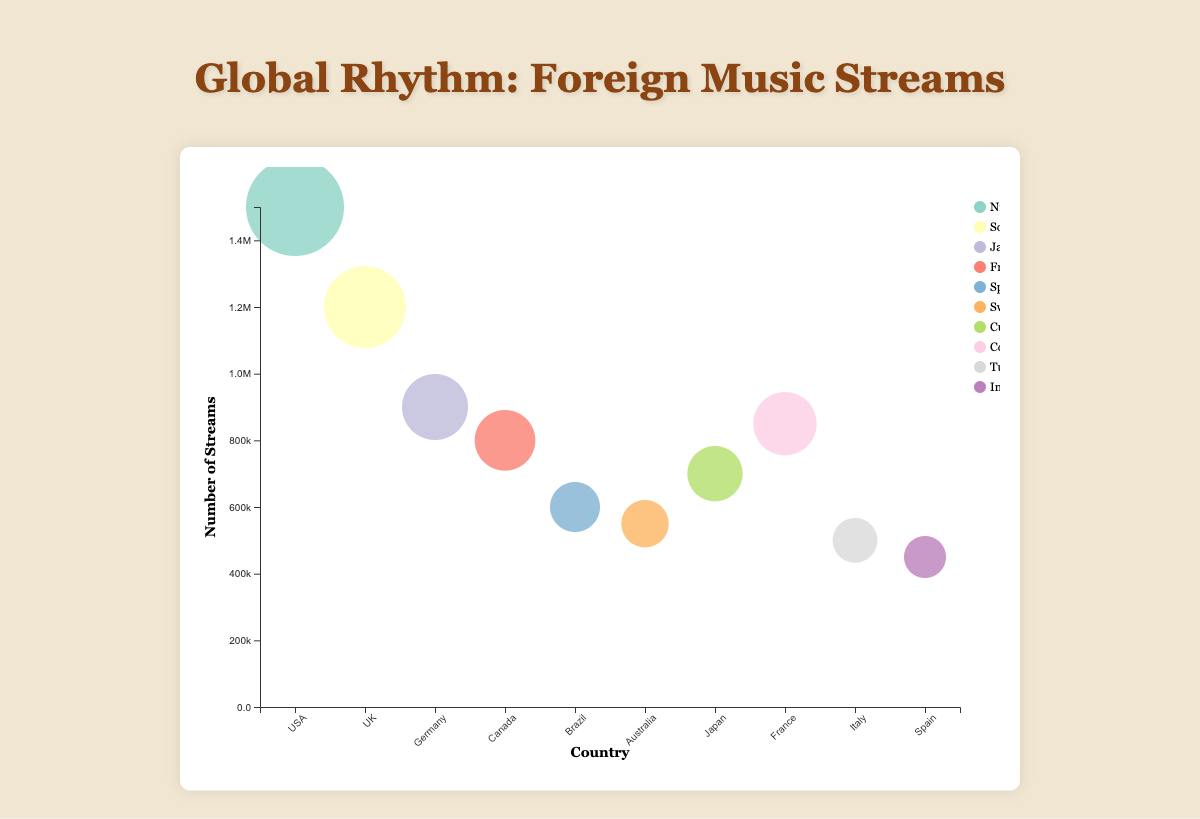Which country streams Burna Boy the most? First, locate the bubble labeled "Burna Boy" (artist from Nigeria). Observe its position on the x-axis to find the corresponding country, which is the USA.
Answer: USA What is the total number of streams for artists originating in Africa? Identify artists from Africa by looking at their origins. Burna Boy (Nigeria) has 1,500,000 streams. He is the only African artist in the figure. Sum the streams.
Answer: 1,500,000 Which artist has the smallest number of streams and in which country? Find the smallest bubble. The smallest one corresponds to A. R. Rahman (India) in Spain.
Answer: A. R. Rahman (Spain) How many countries are represented in the bubble chart? Count the unique countries listed on the x-axis. Countries are USA, UK, Germany, Canada, Brazil, Australia, Japan, France, Italy, Spain.
Answer: 10 Compare the number of streams between Julien Doré in Canada and Bob Marley in Germany. Which artist has more streams? Check the bubbles for Julien Doré (800,000 streams) and Bob Marley (900,000 streams). Compare the numbers.
Answer: Bob Marley Which country streams the most music from Asia? Identify the artists from Asian countries (South Korea, India). Compare the bubble sizes for BTS (1,200,000 streams, UK) and A. R. Rahman (450,000 streams, Spain). The country with the larger bubble streams the most.
Answer: UK What is the average number of streams for artists originating from Europe? Identify European-origin artists: Julien Doré (800,000), Tove Lo (550,000), Shakira (850,000). Sum these values and divide by the number of artists (3): (800,000 + 550,000 + 850,000) / 3.
Answer: 733,333 Which artist's streams in their respective country are closest to 700,000? Locate the bubbles and find the one closest to 700,000 streams. Buena Vista Social Club in Japan has exactly 700,000 streams.
Answer: Buena Vista Social Club (Japan) Does any single bubble stand out significantly from the others in terms of size? Observe all bubbles and note which, if any, stands out due to a much larger radius. Burna Boy's bubble is notably the largest.
Answer: Yes, Burna Boy (USA) 